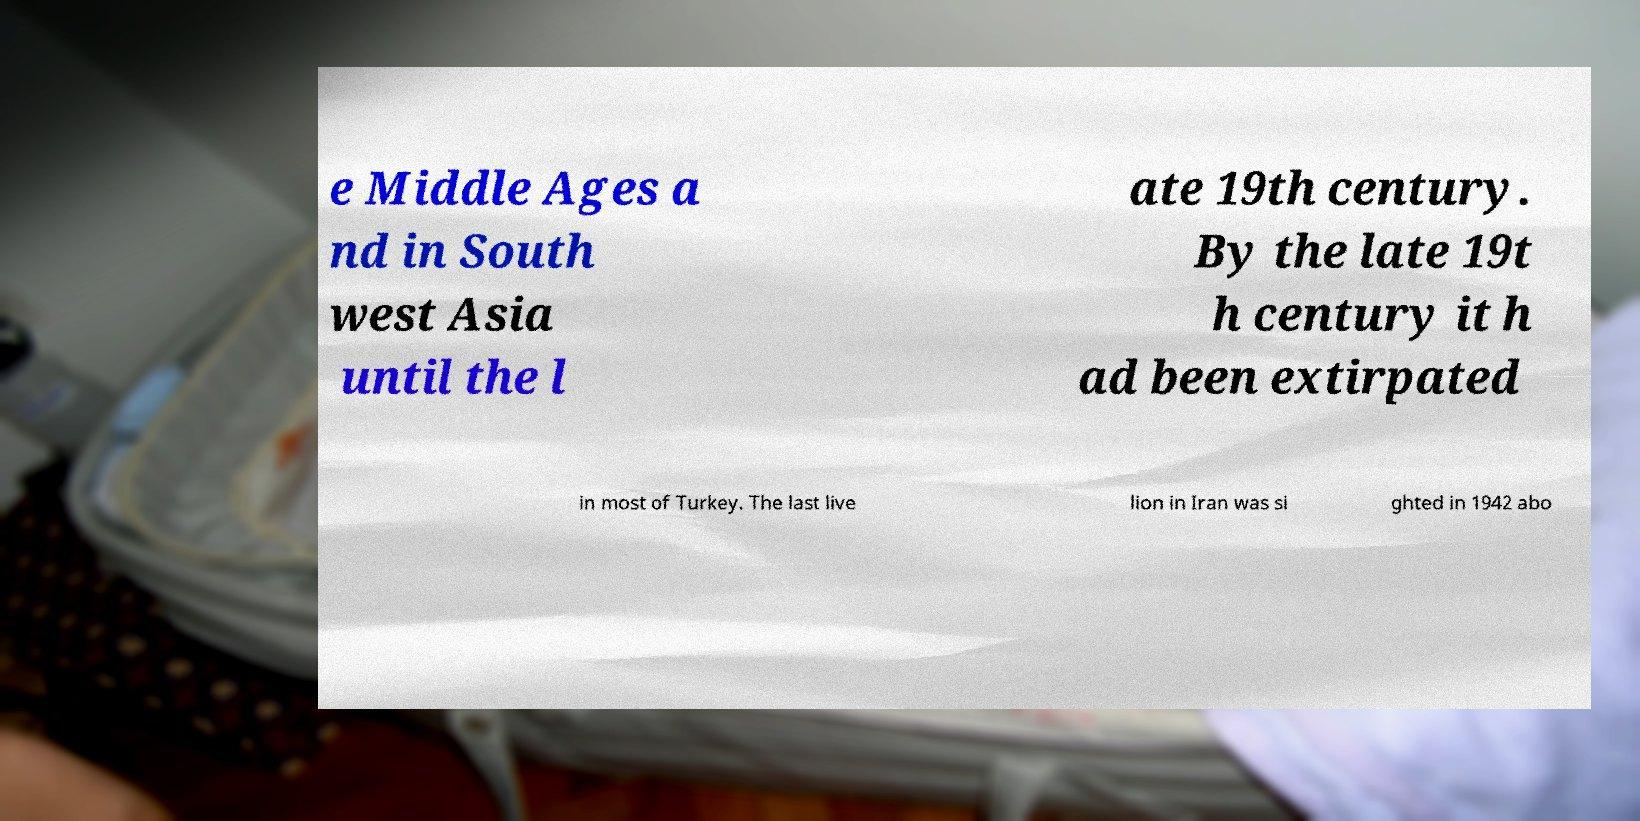There's text embedded in this image that I need extracted. Can you transcribe it verbatim? e Middle Ages a nd in South west Asia until the l ate 19th century. By the late 19t h century it h ad been extirpated in most of Turkey. The last live lion in Iran was si ghted in 1942 abo 